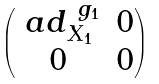Convert formula to latex. <formula><loc_0><loc_0><loc_500><loc_500>\begin{pmatrix} \ a d ^ { \ g _ { 1 } } _ { X _ { 1 } } & 0 \\ 0 & 0 \end{pmatrix}</formula> 